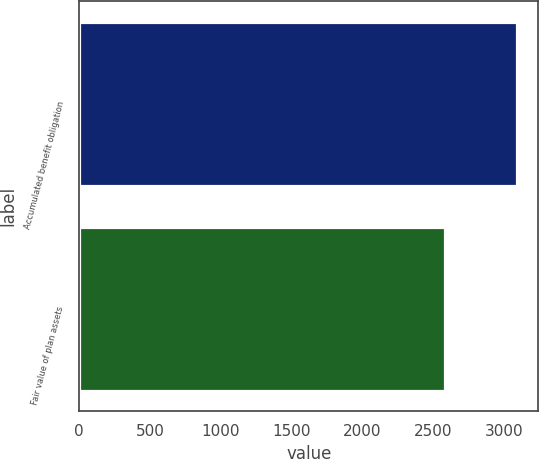Convert chart to OTSL. <chart><loc_0><loc_0><loc_500><loc_500><bar_chart><fcel>Accumulated benefit obligation<fcel>Fair value of plan assets<nl><fcel>3089<fcel>2586<nl></chart> 